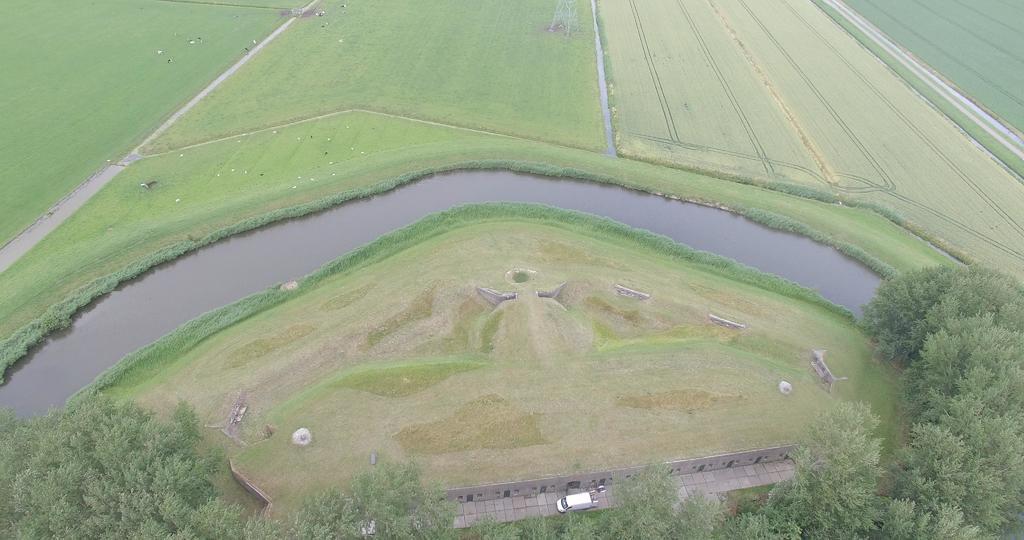In one or two sentences, can you explain what this image depicts? In this image I can see at the bottom there is the vehicle and there are trees on either side. In the middle it is the canal beside the crops. 